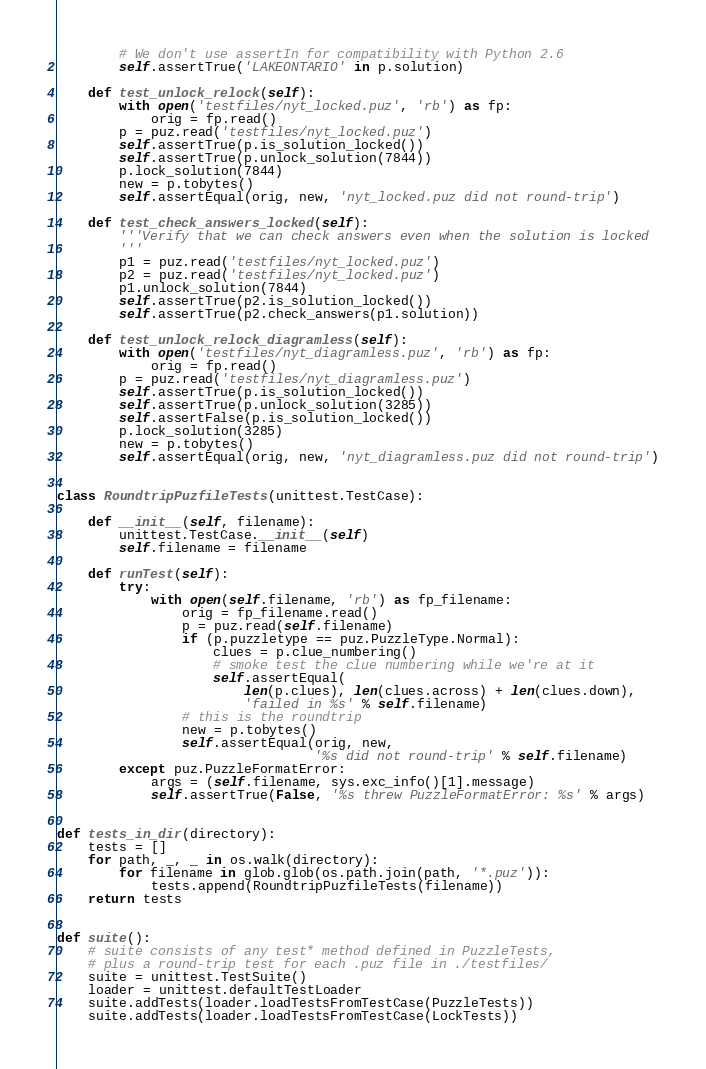Convert code to text. <code><loc_0><loc_0><loc_500><loc_500><_Python_>        # We don't use assertIn for compatibility with Python 2.6
        self.assertTrue('LAKEONTARIO' in p.solution)

    def test_unlock_relock(self):
        with open('testfiles/nyt_locked.puz', 'rb') as fp:
            orig = fp.read()
        p = puz.read('testfiles/nyt_locked.puz')
        self.assertTrue(p.is_solution_locked())
        self.assertTrue(p.unlock_solution(7844))
        p.lock_solution(7844)
        new = p.tobytes()
        self.assertEqual(orig, new, 'nyt_locked.puz did not round-trip')

    def test_check_answers_locked(self):
        '''Verify that we can check answers even when the solution is locked
        '''
        p1 = puz.read('testfiles/nyt_locked.puz')
        p2 = puz.read('testfiles/nyt_locked.puz')
        p1.unlock_solution(7844)
        self.assertTrue(p2.is_solution_locked())
        self.assertTrue(p2.check_answers(p1.solution))

    def test_unlock_relock_diagramless(self):
        with open('testfiles/nyt_diagramless.puz', 'rb') as fp:
            orig = fp.read()
        p = puz.read('testfiles/nyt_diagramless.puz')
        self.assertTrue(p.is_solution_locked())
        self.assertTrue(p.unlock_solution(3285))
        self.assertFalse(p.is_solution_locked())
        p.lock_solution(3285)
        new = p.tobytes()
        self.assertEqual(orig, new, 'nyt_diagramless.puz did not round-trip')


class RoundtripPuzfileTests(unittest.TestCase):

    def __init__(self, filename):
        unittest.TestCase.__init__(self)
        self.filename = filename

    def runTest(self):
        try:
            with open(self.filename, 'rb') as fp_filename:
                orig = fp_filename.read()
                p = puz.read(self.filename)
                if (p.puzzletype == puz.PuzzleType.Normal):
                    clues = p.clue_numbering()
                    # smoke test the clue numbering while we're at it
                    self.assertEqual(
                        len(p.clues), len(clues.across) + len(clues.down),
                        'failed in %s' % self.filename)
                # this is the roundtrip
                new = p.tobytes()
                self.assertEqual(orig, new,
                                 '%s did not round-trip' % self.filename)
        except puz.PuzzleFormatError:
            args = (self.filename, sys.exc_info()[1].message)
            self.assertTrue(False, '%s threw PuzzleFormatError: %s' % args)


def tests_in_dir(directory):
    tests = []
    for path, _, _ in os.walk(directory):
        for filename in glob.glob(os.path.join(path, '*.puz')):
            tests.append(RoundtripPuzfileTests(filename))
    return tests


def suite():
    # suite consists of any test* method defined in PuzzleTests,
    # plus a round-trip test for each .puz file in ./testfiles/
    suite = unittest.TestSuite()
    loader = unittest.defaultTestLoader
    suite.addTests(loader.loadTestsFromTestCase(PuzzleTests))
    suite.addTests(loader.loadTestsFromTestCase(LockTests))</code> 